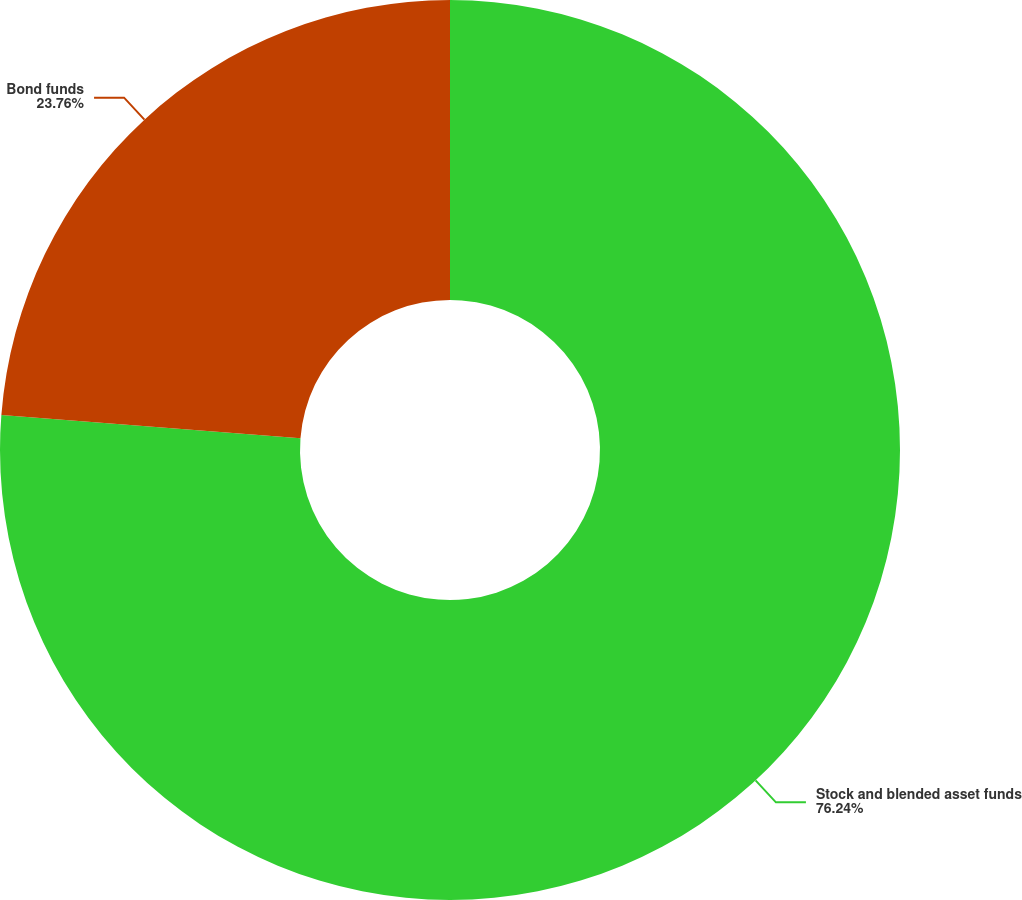Convert chart. <chart><loc_0><loc_0><loc_500><loc_500><pie_chart><fcel>Stock and blended asset funds<fcel>Bond funds<nl><fcel>76.24%<fcel>23.76%<nl></chart> 